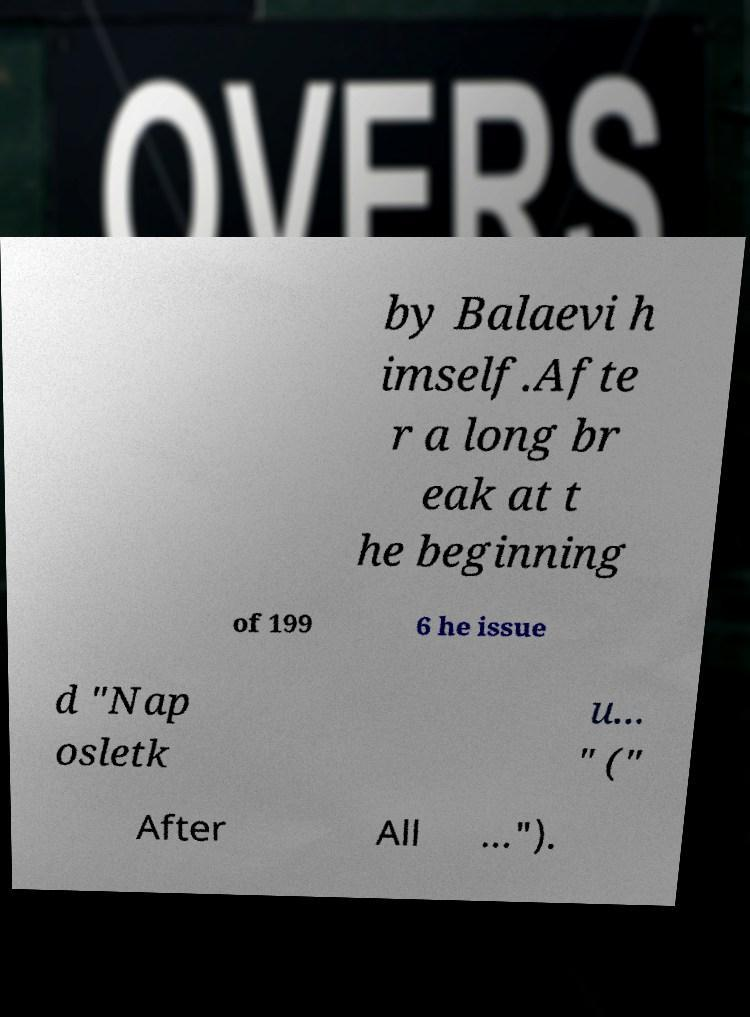I need the written content from this picture converted into text. Can you do that? by Balaevi h imself.Afte r a long br eak at t he beginning of 199 6 he issue d "Nap osletk u... " (" After All ..."). 